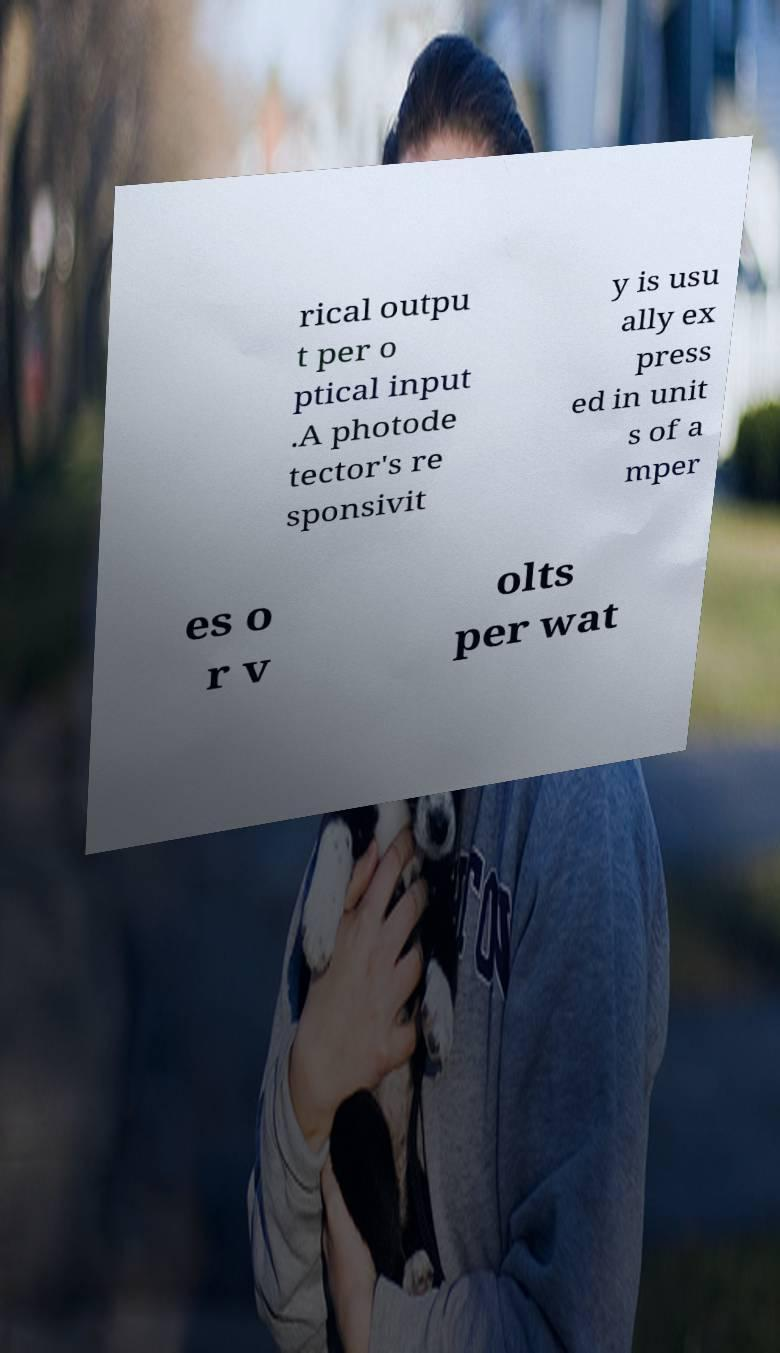There's text embedded in this image that I need extracted. Can you transcribe it verbatim? rical outpu t per o ptical input .A photode tector's re sponsivit y is usu ally ex press ed in unit s of a mper es o r v olts per wat 